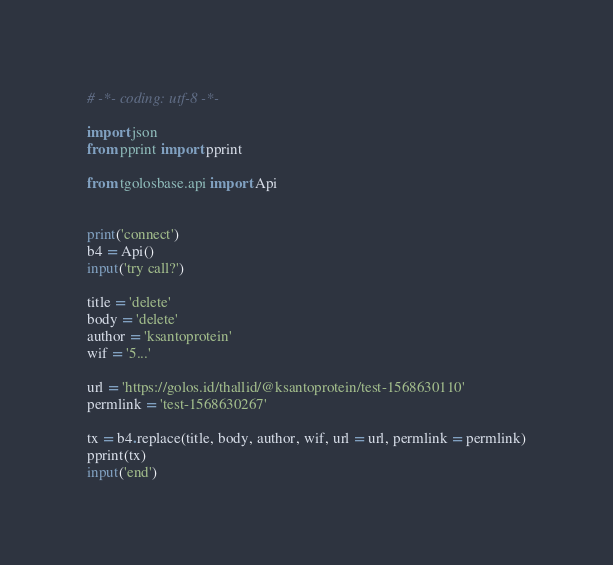<code> <loc_0><loc_0><loc_500><loc_500><_Python_># -*- coding: utf-8 -*-

import json
from pprint import pprint

from tgolosbase.api import Api


print('connect')
b4 = Api()
input('try call?')

title = 'delete'
body = 'delete'
author = 'ksantoprotein'
wif = '5...'

url = 'https://golos.id/thallid/@ksantoprotein/test-1568630110'
permlink = 'test-1568630267'

tx = b4.replace(title, body, author, wif, url = url, permlink = permlink)
pprint(tx)
input('end')</code> 